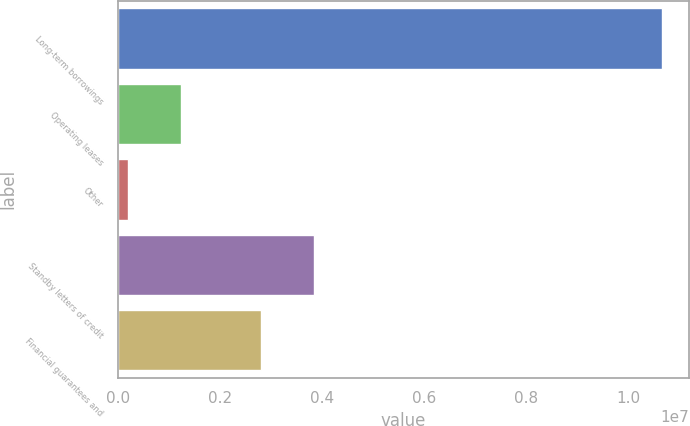Convert chart to OTSL. <chart><loc_0><loc_0><loc_500><loc_500><bar_chart><fcel>Long-term borrowings<fcel>Operating leases<fcel>Other<fcel>Standby letters of credit<fcel>Financial guarantees and<nl><fcel>1.06539e+07<fcel>1.23806e+06<fcel>191859<fcel>3.84052e+06<fcel>2.79432e+06<nl></chart> 